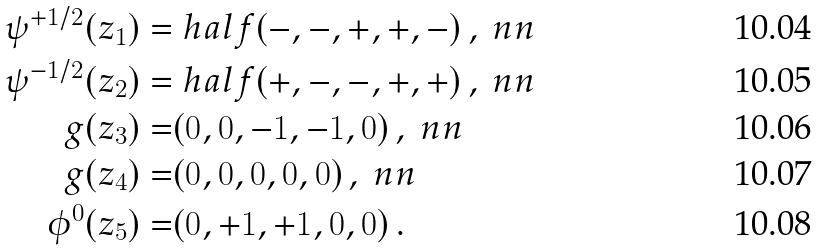<formula> <loc_0><loc_0><loc_500><loc_500>\psi ^ { + 1 / 2 } ( z _ { 1 } ) = & \ h a l f ( - , - , + , + , - ) \, , \ n n \\ \psi ^ { - 1 / 2 } ( z _ { 2 } ) = & \ h a l f ( + , - , - , + , + ) \, , \ n n \\ g ( z _ { 3 } ) = & ( 0 , 0 , - 1 , - 1 , 0 ) \, , \ n n \\ g ( z _ { 4 } ) = & ( 0 , 0 , 0 , 0 , 0 ) \, , \ n n \\ \phi ^ { 0 } ( z _ { 5 } ) = & ( 0 , + 1 , + 1 , 0 , 0 ) \, .</formula> 